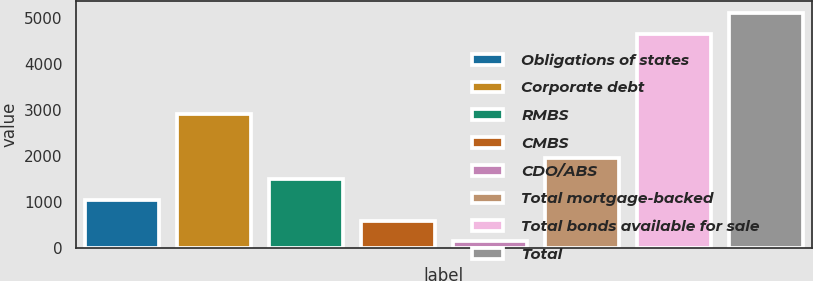<chart> <loc_0><loc_0><loc_500><loc_500><bar_chart><fcel>Obligations of states<fcel>Corporate debt<fcel>RMBS<fcel>CMBS<fcel>CDO/ABS<fcel>Total mortgage-backed<fcel>Total bonds available for sale<fcel>Total<nl><fcel>1051<fcel>2898<fcel>1505.5<fcel>596.5<fcel>142<fcel>1960<fcel>4648<fcel>5102.5<nl></chart> 